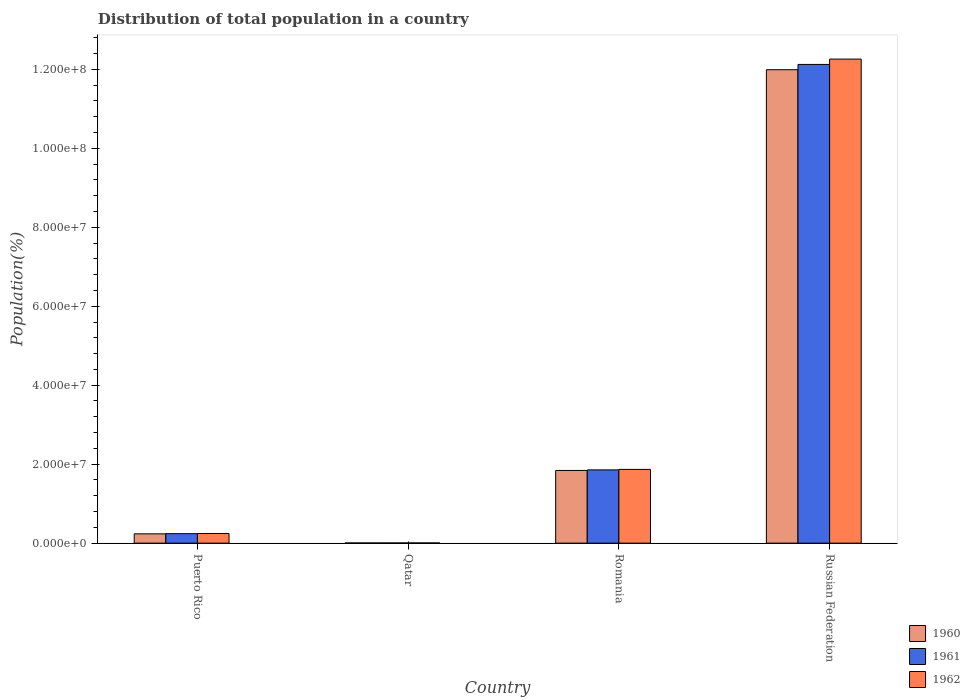Are the number of bars per tick equal to the number of legend labels?
Your answer should be compact. Yes. What is the label of the 1st group of bars from the left?
Provide a short and direct response. Puerto Rico. What is the population of in 1961 in Puerto Rico?
Your response must be concise. 2.40e+06. Across all countries, what is the maximum population of in 1960?
Keep it short and to the point. 1.20e+08. Across all countries, what is the minimum population of in 1962?
Your response must be concise. 5.62e+04. In which country was the population of in 1960 maximum?
Give a very brief answer. Russian Federation. In which country was the population of in 1961 minimum?
Your answer should be very brief. Qatar. What is the total population of in 1962 in the graph?
Your response must be concise. 1.44e+08. What is the difference between the population of in 1961 in Romania and that in Russian Federation?
Ensure brevity in your answer.  -1.03e+08. What is the difference between the population of in 1960 in Russian Federation and the population of in 1961 in Romania?
Provide a short and direct response. 1.01e+08. What is the average population of in 1962 per country?
Make the answer very short. 3.59e+07. What is the difference between the population of of/in 1960 and population of of/in 1961 in Qatar?
Offer a very short reply. -4046. In how many countries, is the population of in 1961 greater than 80000000 %?
Your response must be concise. 1. What is the ratio of the population of in 1961 in Puerto Rico to that in Qatar?
Your response must be concise. 46.73. Is the difference between the population of in 1960 in Puerto Rico and Russian Federation greater than the difference between the population of in 1961 in Puerto Rico and Russian Federation?
Your answer should be compact. Yes. What is the difference between the highest and the second highest population of in 1961?
Keep it short and to the point. 1.03e+08. What is the difference between the highest and the lowest population of in 1962?
Provide a succinct answer. 1.23e+08. What does the 3rd bar from the left in Qatar represents?
Give a very brief answer. 1962. Is it the case that in every country, the sum of the population of in 1962 and population of in 1960 is greater than the population of in 1961?
Offer a terse response. Yes. How many bars are there?
Provide a succinct answer. 12. What is the difference between two consecutive major ticks on the Y-axis?
Your answer should be very brief. 2.00e+07. Are the values on the major ticks of Y-axis written in scientific E-notation?
Provide a succinct answer. Yes. What is the title of the graph?
Ensure brevity in your answer.  Distribution of total population in a country. What is the label or title of the X-axis?
Ensure brevity in your answer.  Country. What is the label or title of the Y-axis?
Ensure brevity in your answer.  Population(%). What is the Population(%) of 1960 in Puerto Rico?
Your answer should be compact. 2.36e+06. What is the Population(%) in 1961 in Puerto Rico?
Your response must be concise. 2.40e+06. What is the Population(%) in 1962 in Puerto Rico?
Offer a terse response. 2.45e+06. What is the Population(%) in 1960 in Qatar?
Offer a very short reply. 4.73e+04. What is the Population(%) of 1961 in Qatar?
Give a very brief answer. 5.14e+04. What is the Population(%) of 1962 in Qatar?
Make the answer very short. 5.62e+04. What is the Population(%) of 1960 in Romania?
Provide a succinct answer. 1.84e+07. What is the Population(%) in 1961 in Romania?
Make the answer very short. 1.86e+07. What is the Population(%) of 1962 in Romania?
Make the answer very short. 1.87e+07. What is the Population(%) in 1960 in Russian Federation?
Give a very brief answer. 1.20e+08. What is the Population(%) in 1961 in Russian Federation?
Your response must be concise. 1.21e+08. What is the Population(%) of 1962 in Russian Federation?
Your answer should be very brief. 1.23e+08. Across all countries, what is the maximum Population(%) of 1960?
Provide a short and direct response. 1.20e+08. Across all countries, what is the maximum Population(%) of 1961?
Your response must be concise. 1.21e+08. Across all countries, what is the maximum Population(%) in 1962?
Your answer should be compact. 1.23e+08. Across all countries, what is the minimum Population(%) in 1960?
Provide a short and direct response. 4.73e+04. Across all countries, what is the minimum Population(%) of 1961?
Keep it short and to the point. 5.14e+04. Across all countries, what is the minimum Population(%) in 1962?
Your response must be concise. 5.62e+04. What is the total Population(%) in 1960 in the graph?
Your answer should be very brief. 1.41e+08. What is the total Population(%) in 1961 in the graph?
Provide a succinct answer. 1.42e+08. What is the total Population(%) of 1962 in the graph?
Ensure brevity in your answer.  1.44e+08. What is the difference between the Population(%) of 1960 in Puerto Rico and that in Qatar?
Your answer should be compact. 2.31e+06. What is the difference between the Population(%) in 1961 in Puerto Rico and that in Qatar?
Your answer should be very brief. 2.35e+06. What is the difference between the Population(%) of 1962 in Puerto Rico and that in Qatar?
Make the answer very short. 2.39e+06. What is the difference between the Population(%) in 1960 in Puerto Rico and that in Romania?
Your answer should be compact. -1.60e+07. What is the difference between the Population(%) of 1961 in Puerto Rico and that in Romania?
Ensure brevity in your answer.  -1.62e+07. What is the difference between the Population(%) in 1962 in Puerto Rico and that in Romania?
Offer a very short reply. -1.62e+07. What is the difference between the Population(%) in 1960 in Puerto Rico and that in Russian Federation?
Give a very brief answer. -1.18e+08. What is the difference between the Population(%) in 1961 in Puerto Rico and that in Russian Federation?
Make the answer very short. -1.19e+08. What is the difference between the Population(%) in 1962 in Puerto Rico and that in Russian Federation?
Provide a short and direct response. -1.20e+08. What is the difference between the Population(%) in 1960 in Qatar and that in Romania?
Your response must be concise. -1.84e+07. What is the difference between the Population(%) of 1961 in Qatar and that in Romania?
Your response must be concise. -1.85e+07. What is the difference between the Population(%) of 1962 in Qatar and that in Romania?
Give a very brief answer. -1.86e+07. What is the difference between the Population(%) in 1960 in Qatar and that in Russian Federation?
Your response must be concise. -1.20e+08. What is the difference between the Population(%) of 1961 in Qatar and that in Russian Federation?
Offer a terse response. -1.21e+08. What is the difference between the Population(%) of 1962 in Qatar and that in Russian Federation?
Your answer should be very brief. -1.23e+08. What is the difference between the Population(%) in 1960 in Romania and that in Russian Federation?
Keep it short and to the point. -1.01e+08. What is the difference between the Population(%) of 1961 in Romania and that in Russian Federation?
Offer a very short reply. -1.03e+08. What is the difference between the Population(%) of 1962 in Romania and that in Russian Federation?
Your answer should be very brief. -1.04e+08. What is the difference between the Population(%) of 1960 in Puerto Rico and the Population(%) of 1961 in Qatar?
Your answer should be compact. 2.31e+06. What is the difference between the Population(%) in 1960 in Puerto Rico and the Population(%) in 1962 in Qatar?
Offer a terse response. 2.30e+06. What is the difference between the Population(%) in 1961 in Puerto Rico and the Population(%) in 1962 in Qatar?
Provide a short and direct response. 2.34e+06. What is the difference between the Population(%) of 1960 in Puerto Rico and the Population(%) of 1961 in Romania?
Provide a short and direct response. -1.62e+07. What is the difference between the Population(%) of 1960 in Puerto Rico and the Population(%) of 1962 in Romania?
Provide a succinct answer. -1.63e+07. What is the difference between the Population(%) of 1961 in Puerto Rico and the Population(%) of 1962 in Romania?
Offer a terse response. -1.63e+07. What is the difference between the Population(%) in 1960 in Puerto Rico and the Population(%) in 1961 in Russian Federation?
Make the answer very short. -1.19e+08. What is the difference between the Population(%) in 1960 in Puerto Rico and the Population(%) in 1962 in Russian Federation?
Give a very brief answer. -1.20e+08. What is the difference between the Population(%) of 1961 in Puerto Rico and the Population(%) of 1962 in Russian Federation?
Offer a very short reply. -1.20e+08. What is the difference between the Population(%) of 1960 in Qatar and the Population(%) of 1961 in Romania?
Ensure brevity in your answer.  -1.85e+07. What is the difference between the Population(%) of 1960 in Qatar and the Population(%) of 1962 in Romania?
Your answer should be compact. -1.86e+07. What is the difference between the Population(%) in 1961 in Qatar and the Population(%) in 1962 in Romania?
Offer a terse response. -1.86e+07. What is the difference between the Population(%) of 1960 in Qatar and the Population(%) of 1961 in Russian Federation?
Your answer should be compact. -1.21e+08. What is the difference between the Population(%) of 1960 in Qatar and the Population(%) of 1962 in Russian Federation?
Provide a succinct answer. -1.23e+08. What is the difference between the Population(%) in 1961 in Qatar and the Population(%) in 1962 in Russian Federation?
Offer a very short reply. -1.23e+08. What is the difference between the Population(%) in 1960 in Romania and the Population(%) in 1961 in Russian Federation?
Offer a very short reply. -1.03e+08. What is the difference between the Population(%) of 1960 in Romania and the Population(%) of 1962 in Russian Federation?
Your response must be concise. -1.04e+08. What is the difference between the Population(%) in 1961 in Romania and the Population(%) in 1962 in Russian Federation?
Provide a succinct answer. -1.04e+08. What is the average Population(%) in 1960 per country?
Offer a terse response. 3.52e+07. What is the average Population(%) of 1961 per country?
Give a very brief answer. 3.56e+07. What is the average Population(%) in 1962 per country?
Provide a succinct answer. 3.59e+07. What is the difference between the Population(%) of 1960 and Population(%) of 1961 in Puerto Rico?
Make the answer very short. -4.17e+04. What is the difference between the Population(%) in 1960 and Population(%) in 1962 in Puerto Rico?
Offer a terse response. -9.23e+04. What is the difference between the Population(%) of 1961 and Population(%) of 1962 in Puerto Rico?
Offer a very short reply. -5.06e+04. What is the difference between the Population(%) of 1960 and Population(%) of 1961 in Qatar?
Ensure brevity in your answer.  -4046. What is the difference between the Population(%) in 1960 and Population(%) in 1962 in Qatar?
Offer a terse response. -8878. What is the difference between the Population(%) in 1961 and Population(%) in 1962 in Qatar?
Ensure brevity in your answer.  -4832. What is the difference between the Population(%) in 1960 and Population(%) in 1961 in Romania?
Give a very brief answer. -1.48e+05. What is the difference between the Population(%) of 1960 and Population(%) of 1962 in Romania?
Ensure brevity in your answer.  -2.70e+05. What is the difference between the Population(%) in 1961 and Population(%) in 1962 in Romania?
Offer a very short reply. -1.21e+05. What is the difference between the Population(%) in 1960 and Population(%) in 1961 in Russian Federation?
Your answer should be compact. -1.34e+06. What is the difference between the Population(%) of 1960 and Population(%) of 1962 in Russian Federation?
Your response must be concise. -2.69e+06. What is the difference between the Population(%) of 1961 and Population(%) of 1962 in Russian Federation?
Your answer should be compact. -1.36e+06. What is the ratio of the Population(%) of 1960 in Puerto Rico to that in Qatar?
Offer a terse response. 49.84. What is the ratio of the Population(%) in 1961 in Puerto Rico to that in Qatar?
Provide a short and direct response. 46.73. What is the ratio of the Population(%) of 1962 in Puerto Rico to that in Qatar?
Your response must be concise. 43.61. What is the ratio of the Population(%) of 1960 in Puerto Rico to that in Romania?
Your answer should be compact. 0.13. What is the ratio of the Population(%) in 1961 in Puerto Rico to that in Romania?
Your answer should be compact. 0.13. What is the ratio of the Population(%) of 1962 in Puerto Rico to that in Romania?
Offer a very short reply. 0.13. What is the ratio of the Population(%) of 1960 in Puerto Rico to that in Russian Federation?
Your answer should be compact. 0.02. What is the ratio of the Population(%) of 1961 in Puerto Rico to that in Russian Federation?
Ensure brevity in your answer.  0.02. What is the ratio of the Population(%) in 1960 in Qatar to that in Romania?
Your answer should be compact. 0. What is the ratio of the Population(%) in 1961 in Qatar to that in Romania?
Your answer should be very brief. 0. What is the ratio of the Population(%) in 1962 in Qatar to that in Romania?
Ensure brevity in your answer.  0. What is the ratio of the Population(%) of 1961 in Qatar to that in Russian Federation?
Your response must be concise. 0. What is the ratio of the Population(%) in 1960 in Romania to that in Russian Federation?
Offer a very short reply. 0.15. What is the ratio of the Population(%) in 1961 in Romania to that in Russian Federation?
Keep it short and to the point. 0.15. What is the ratio of the Population(%) in 1962 in Romania to that in Russian Federation?
Your answer should be very brief. 0.15. What is the difference between the highest and the second highest Population(%) in 1960?
Provide a succinct answer. 1.01e+08. What is the difference between the highest and the second highest Population(%) of 1961?
Ensure brevity in your answer.  1.03e+08. What is the difference between the highest and the second highest Population(%) of 1962?
Your response must be concise. 1.04e+08. What is the difference between the highest and the lowest Population(%) of 1960?
Make the answer very short. 1.20e+08. What is the difference between the highest and the lowest Population(%) in 1961?
Make the answer very short. 1.21e+08. What is the difference between the highest and the lowest Population(%) in 1962?
Your answer should be compact. 1.23e+08. 